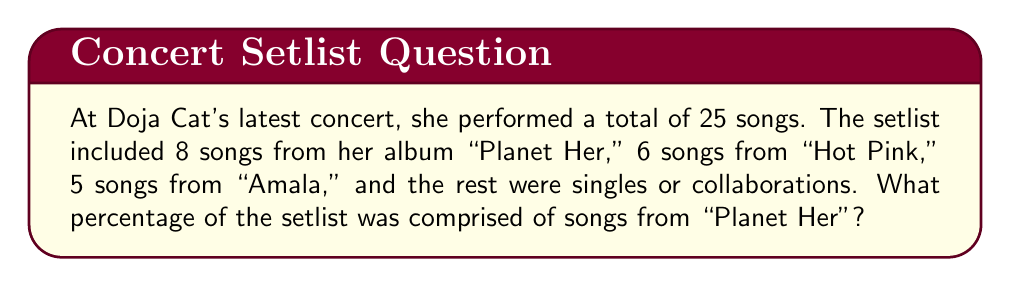Teach me how to tackle this problem. To solve this problem, we need to follow these steps:

1. Identify the total number of songs in the setlist:
   Total songs = 25

2. Identify the number of songs from "Planet Her":
   Songs from "Planet Her" = 8

3. Calculate the percentage using the formula:
   $$ \text{Percentage} = \frac{\text{Number of songs from "Planet Her"}}{\text{Total number of songs}} \times 100\% $$

4. Plug in the values:
   $$ \text{Percentage} = \frac{8}{25} \times 100\% $$

5. Simplify the fraction:
   $$ \text{Percentage} = 0.32 \times 100\% $$

6. Calculate the final percentage:
   $$ \text{Percentage} = 32\% $$

Therefore, songs from "Planet Her" comprised 32% of the setlist.
Answer: 32% 